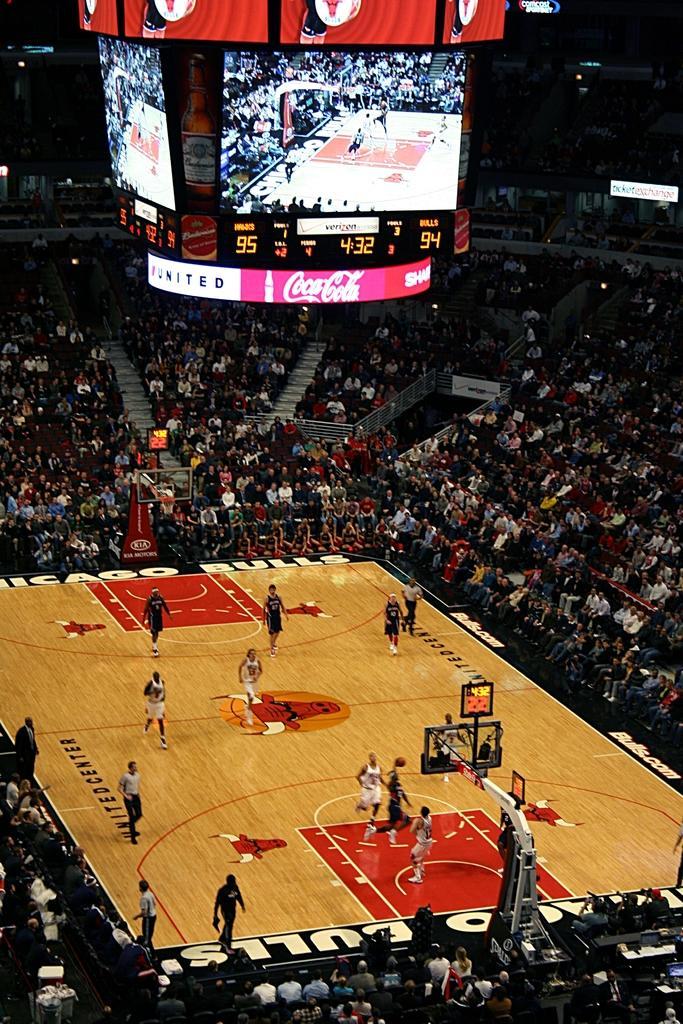Please provide a concise description of this image. In this image we can see a basketball court. There are few people playing. And there is a stadium. And we can see many people sitting. Also there are steps and there is a screen. And there is a banner. 